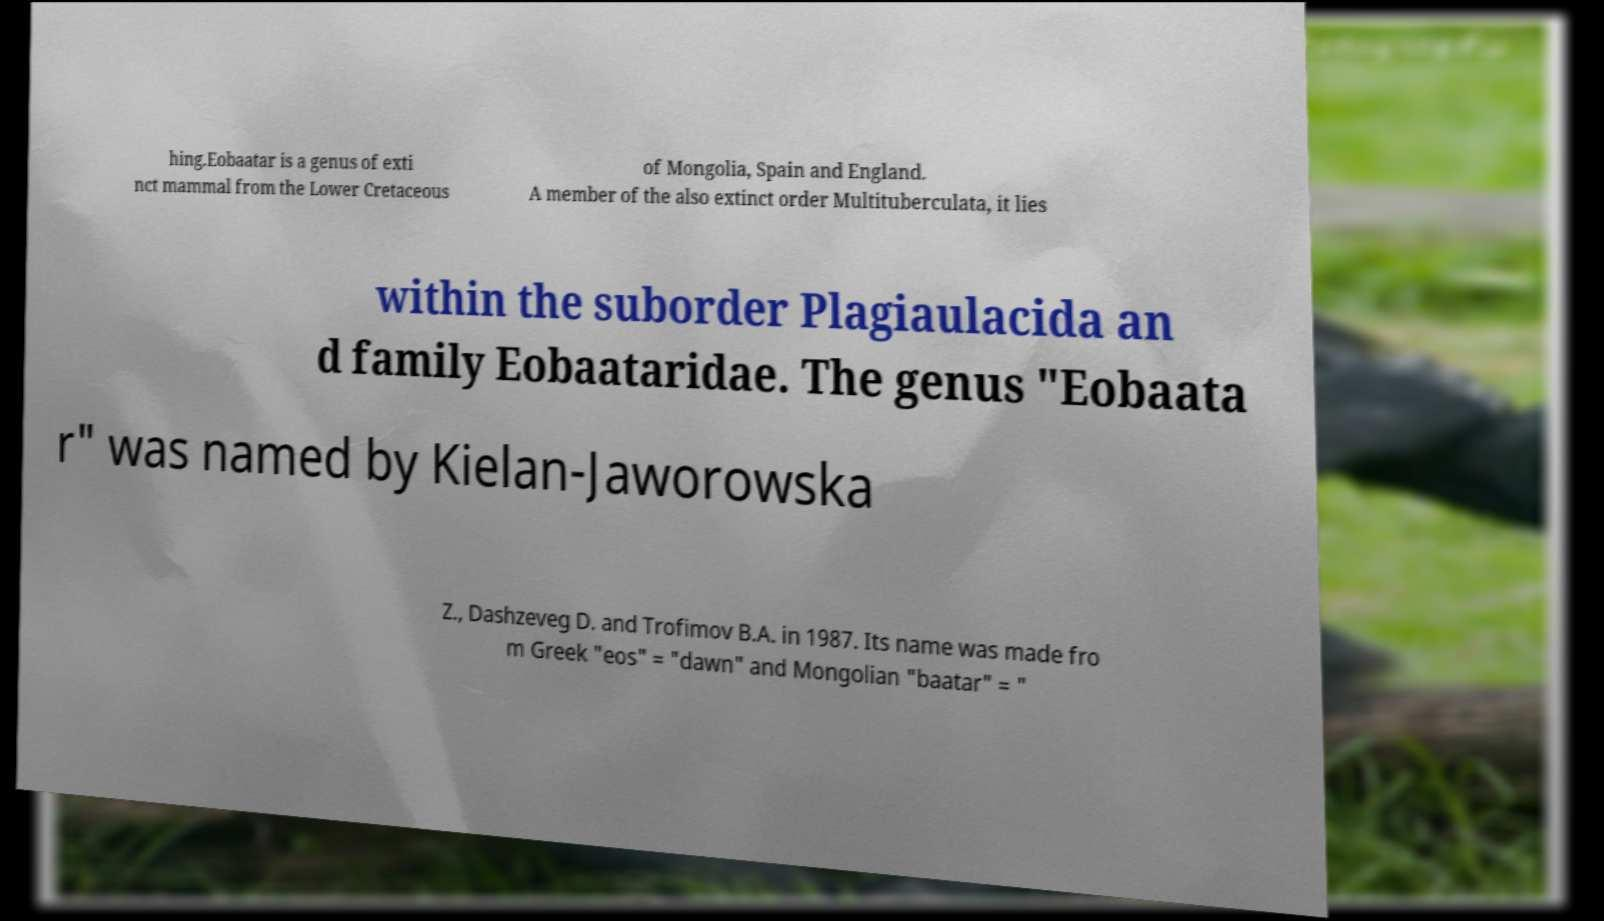What messages or text are displayed in this image? I need them in a readable, typed format. hing.Eobaatar is a genus of exti nct mammal from the Lower Cretaceous of Mongolia, Spain and England. A member of the also extinct order Multituberculata, it lies within the suborder Plagiaulacida an d family Eobaataridae. The genus "Eobaata r" was named by Kielan-Jaworowska Z., Dashzeveg D. and Trofimov B.A. in 1987. Its name was made fro m Greek "eos" = "dawn" and Mongolian "baatar" = " 